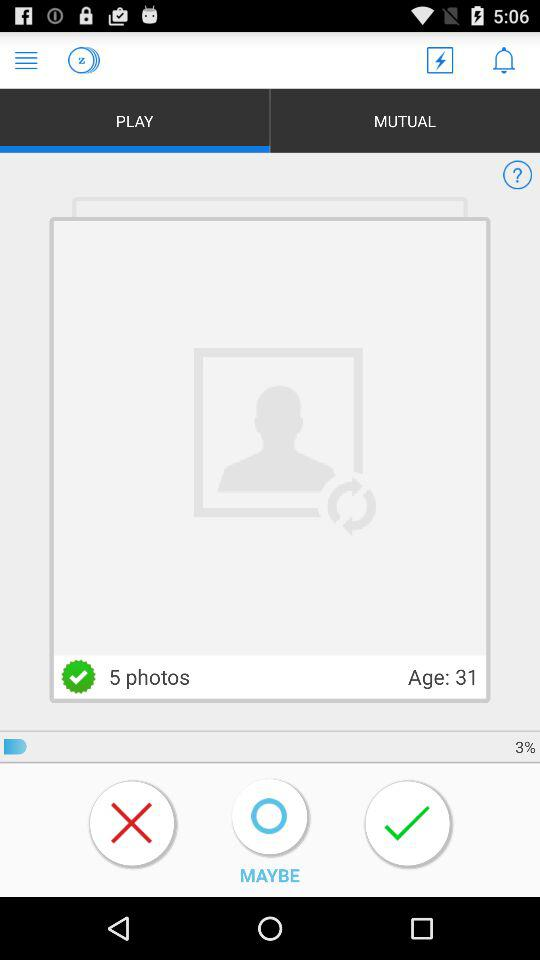How much of the profile has been completed? The profile has been completed to 3%. 